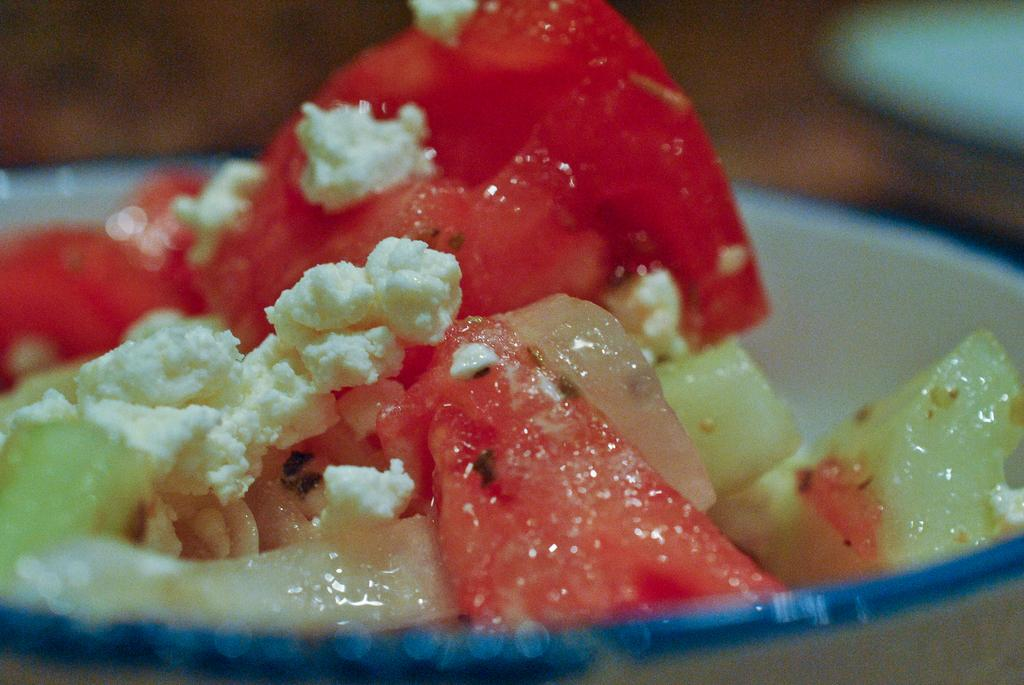What is in the bowl that is visible in the image? There are food items in a bowl in the image. What is applied to the food items in the image? There is cream on the food items. How would you describe the background of the image? The background of the image is blurred. Can you identify any objects in the background of the image? Yes, there are objects visible in the background of the image. How many snakes are slithering around the food items in the image? There are no snakes present in the image; it only features food items and cream. What type of soap is used to clean the objects in the background of the image? There is no soap or cleaning activity mentioned in the image; it only shows food items, cream, and objects in the background. 